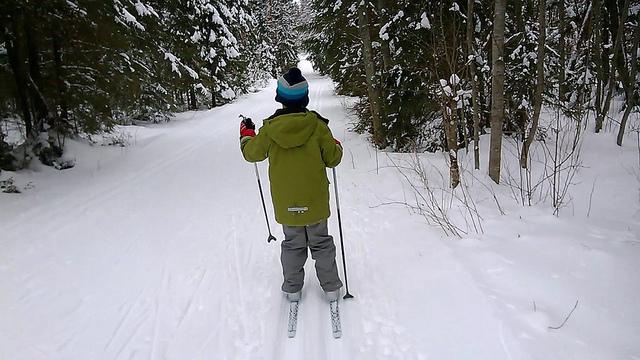What are the weather conditions in the photo?
Short answer required. Snowy. What color are the skiis?
Concise answer only. White. What color is his jacket?
Quick response, please. Green. What is the child riding on?
Keep it brief. Skis. 